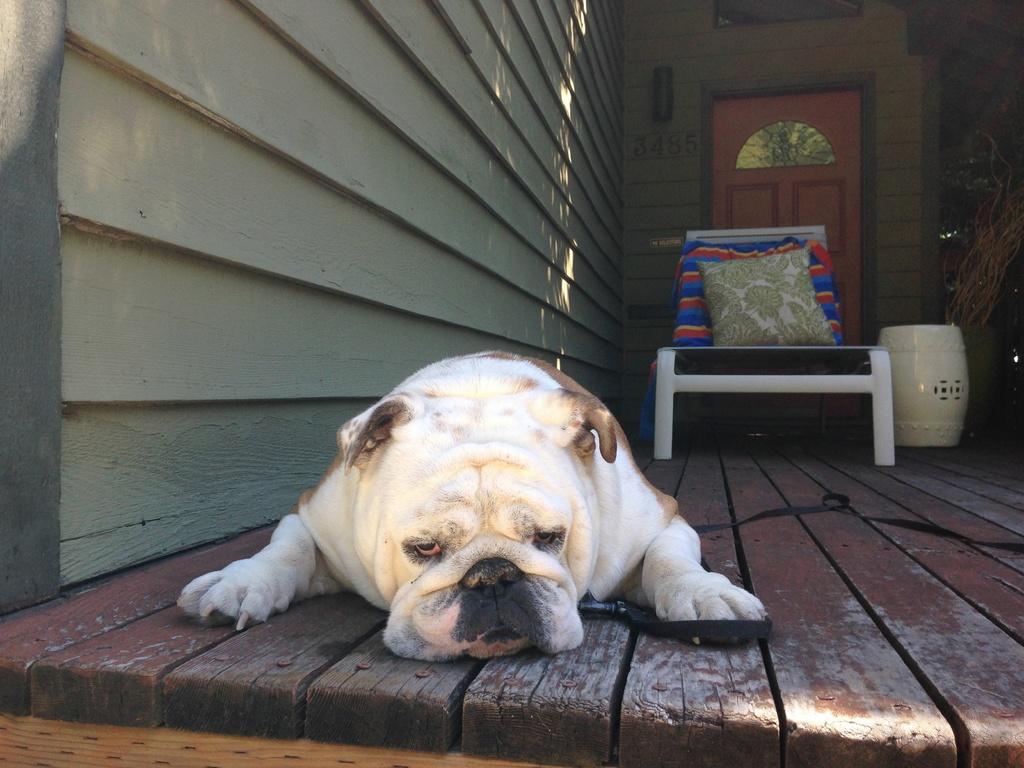Describe this image in one or two sentences. In this picture there is a dog. In the background there is a chair and pillow and a door. 